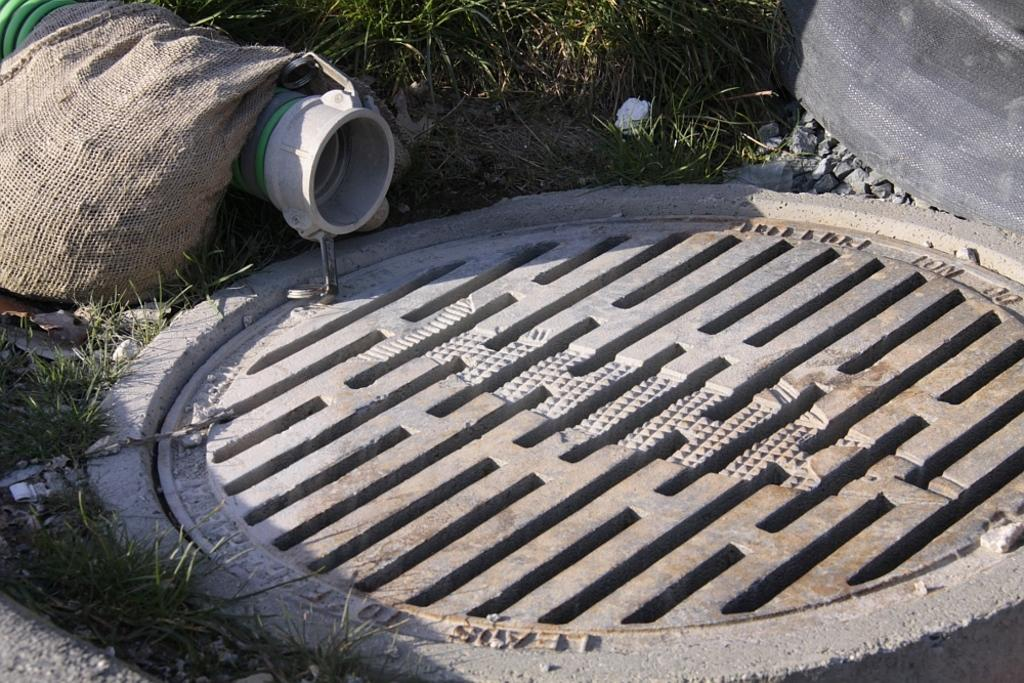What type of imperfection can be seen in the image? There is a pothole in the image. What type of vegetation is on the left side of the image? There is grass on the left side of the image. What type of material is also present on the left side of the image? There are stones on the left side of the image. What object is on the left side of the image, near the grass and stones? There is a bag on the left side of the image. What type of structure is on the left side of the image, near the grass and stones? There is a pipe on the left side of the image. What type of vegetation is at the top of the image? There is grass at the top of the image. What type of material is also present at the top of the image? There are stones at the top of the image. What object is at the top of the image, near the grass and stones? There is an object at the top of the image. How many fingers can be seen pointing at the pothole in the image? There are no fingers visible in the image, as it only shows a pothole, grass, stones, a bag, a pipe, and an object. 